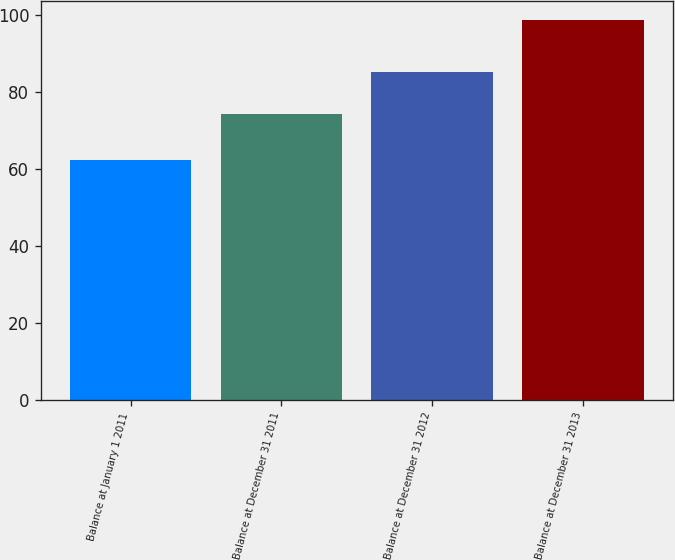Convert chart. <chart><loc_0><loc_0><loc_500><loc_500><bar_chart><fcel>Balance at January 1 2011<fcel>Balance at December 31 2011<fcel>Balance at December 31 2012<fcel>Balance at December 31 2013<nl><fcel>62.3<fcel>74.4<fcel>85.1<fcel>98.8<nl></chart> 